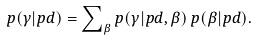Convert formula to latex. <formula><loc_0><loc_0><loc_500><loc_500>p ( \gamma | p d ) = \sum \nolimits _ { \beta } p ( \gamma | p d , \beta ) \, p ( \beta | p d ) .</formula> 